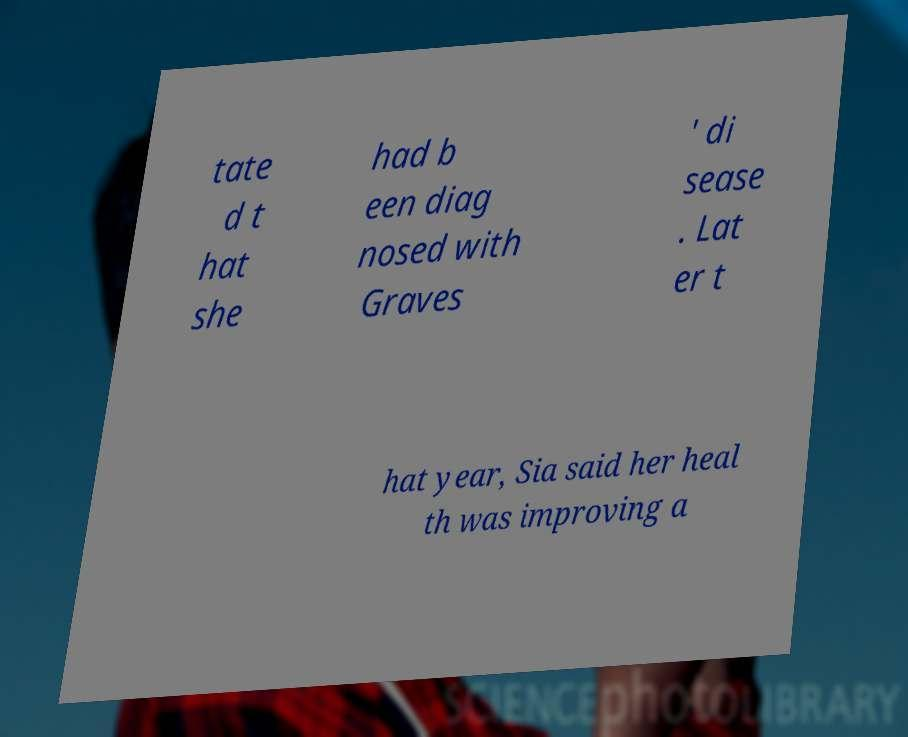Please identify and transcribe the text found in this image. tate d t hat she had b een diag nosed with Graves ' di sease . Lat er t hat year, Sia said her heal th was improving a 